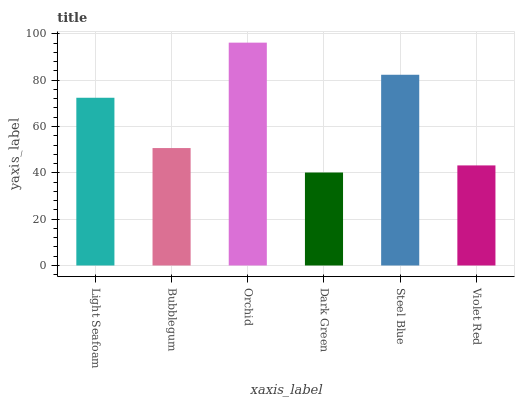Is Dark Green the minimum?
Answer yes or no. Yes. Is Orchid the maximum?
Answer yes or no. Yes. Is Bubblegum the minimum?
Answer yes or no. No. Is Bubblegum the maximum?
Answer yes or no. No. Is Light Seafoam greater than Bubblegum?
Answer yes or no. Yes. Is Bubblegum less than Light Seafoam?
Answer yes or no. Yes. Is Bubblegum greater than Light Seafoam?
Answer yes or no. No. Is Light Seafoam less than Bubblegum?
Answer yes or no. No. Is Light Seafoam the high median?
Answer yes or no. Yes. Is Bubblegum the low median?
Answer yes or no. Yes. Is Violet Red the high median?
Answer yes or no. No. Is Dark Green the low median?
Answer yes or no. No. 